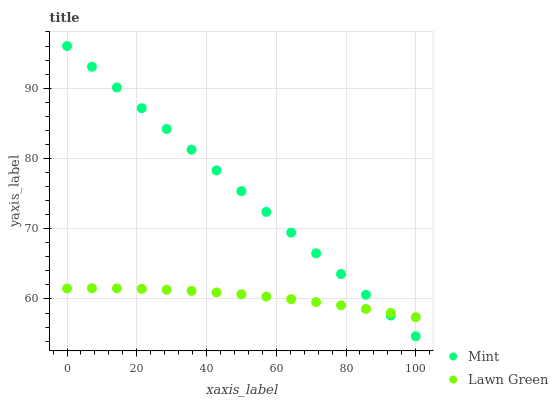Does Lawn Green have the minimum area under the curve?
Answer yes or no. Yes. Does Mint have the maximum area under the curve?
Answer yes or no. Yes. Does Mint have the minimum area under the curve?
Answer yes or no. No. Is Mint the smoothest?
Answer yes or no. Yes. Is Lawn Green the roughest?
Answer yes or no. Yes. Is Mint the roughest?
Answer yes or no. No. Does Mint have the lowest value?
Answer yes or no. Yes. Does Mint have the highest value?
Answer yes or no. Yes. Does Lawn Green intersect Mint?
Answer yes or no. Yes. Is Lawn Green less than Mint?
Answer yes or no. No. Is Lawn Green greater than Mint?
Answer yes or no. No. 